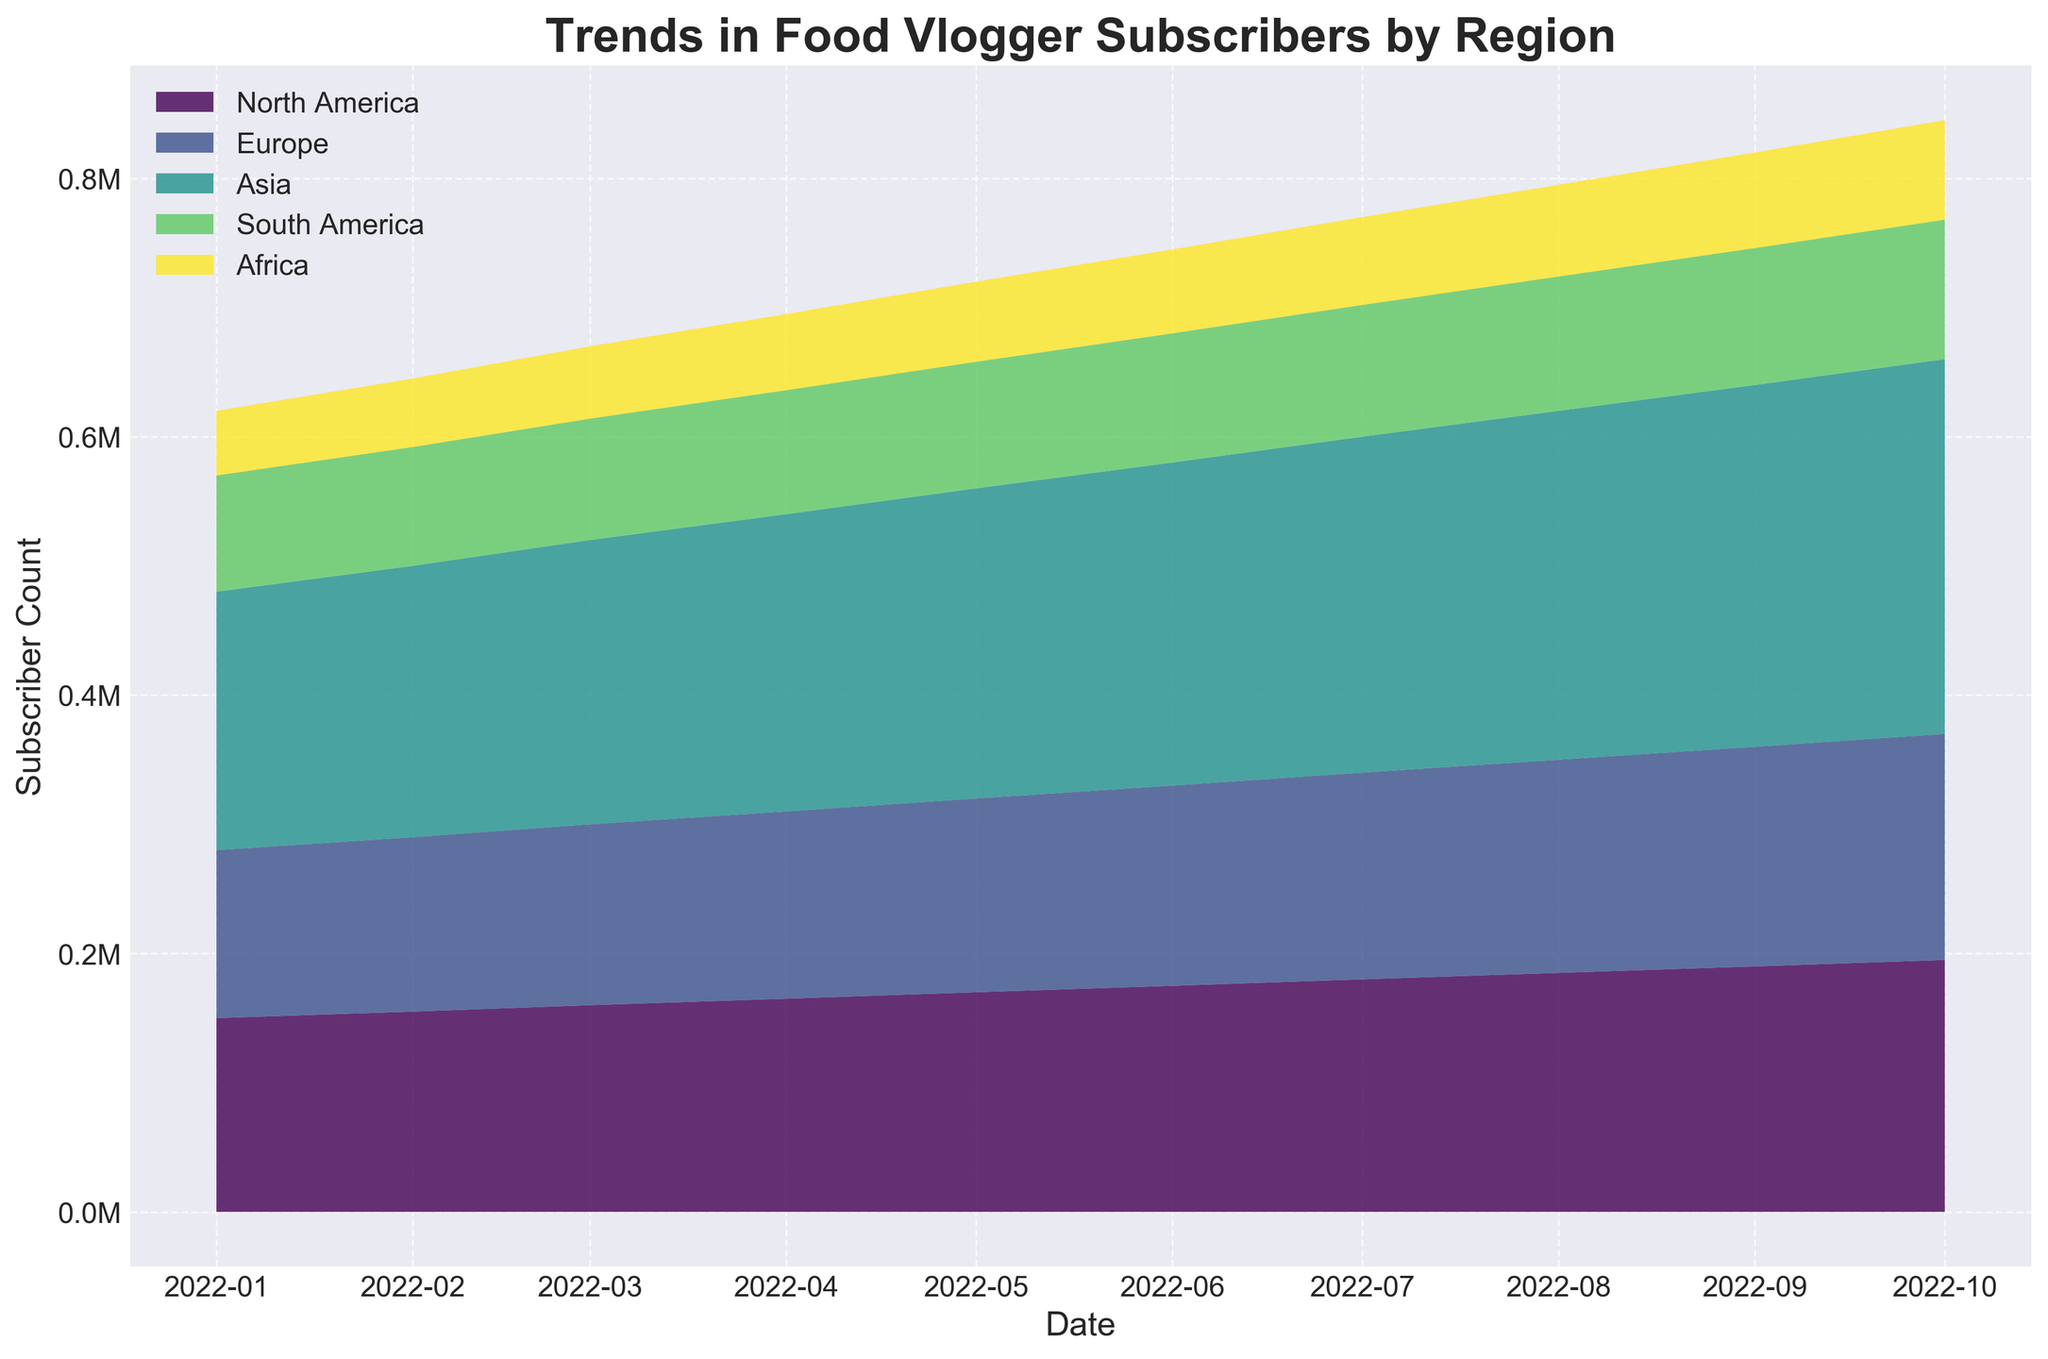What is the title of the figure? The title is usually located at the top of the figure and provides a summary of what the graph represents.
Answer: Trends in Food Vlogger Subscribers by Region Which region had the highest subscriber count in October 2022? By looking at the topmost layer of the stacked area at the rightmost point (October 2022), the top layer color corresponds to Asia.
Answer: Asia How did North America's subscriber count change from January to October 2022? North America's subscriber count started at 150,000 in January and increased consistently each month, reaching 195,000 by October. You can trace the bottom-most part of the stack through the timeline for North America.
Answer: Increased Compare the subscriber growth trends of South America and Africa. Which grew more steadily? By observing the smoothness of the layers for both South America and Africa, Africa's layer has a more uniform upward slope in comparison to the slightly more variable slope of South America's layer.
Answer: Africa What was the overall trend in subscriber counts across all regions from January to October 2022? The sum of all layers shows an overall increasing trend as the highest point on the y-axis rises consistently from left to right.
Answer: Increasing Did any region experience a decrease in subscriber count at any point? By observing the individual layers at each month, none of them show a downward slope at any point. Each region's layer seems to be increasing every month.
Answer: No Estimate the total subscriber count for all regions combined in October 2022. The total height of the stacked graph at the far right end (October 2022) visually adds up the layers. With the highest level being around 1,045,000.
Answer: Approximately 1,045,000 Which region showed the most significant increase in subscribers from September to October 2022? By focusing on the relative increase in the thickness of each region's layer from September to October, Asia's layer shows the largest increase, approximately by 10,000.
Answer: Asia How many regions are represented in this figure? The distinct number of colored layers represents different regions. By counting the layers in the graph, we identify five regions.
Answer: 5 